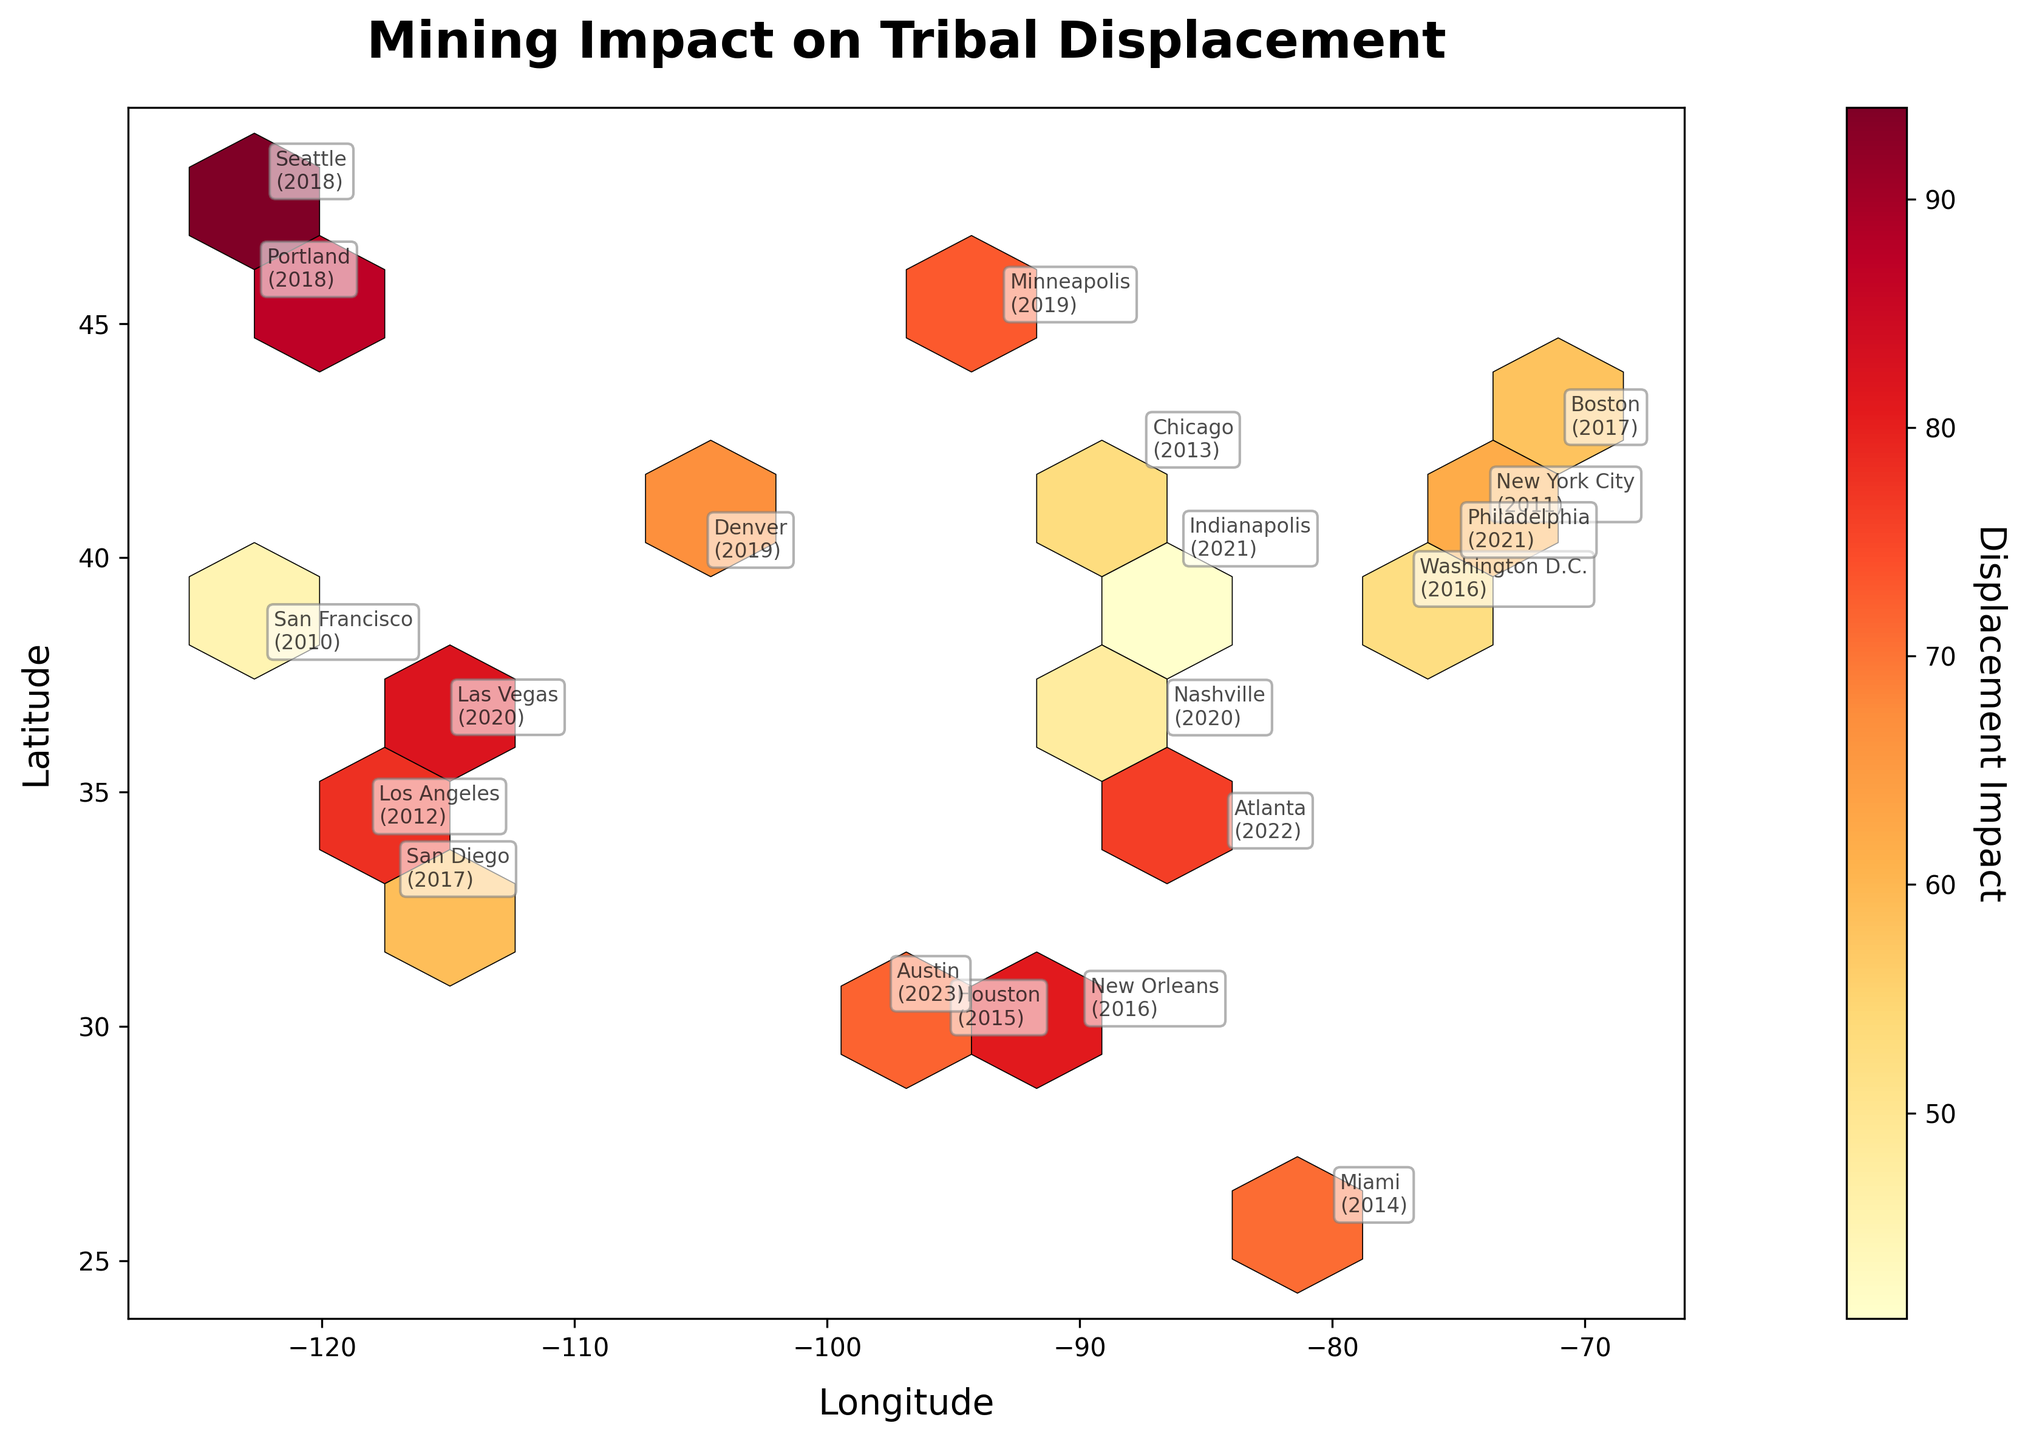What is the color indicating the highest displacement impact on the plot? The color scale denotes displacement impact where darker shades indicate higher impacts. The color bar shows the transition from light yellow to dark red. Dark red represents the highest displacement impact.
Answer: Dark red What is the title of the hexbin plot? The title of the plot is prominently displayed at the top. It is larger and in bold font.
Answer: Mining Impact on Tribal Displacement Which city had the highest displacement impact in 2020? By examining the specific annotations, we identify Las Vegas with a significant displacement impact in 2020.
Answer: Las Vegas How does the displacement impact in Portland (2018) compare to that in San Diego (2017)? By looking at the annotations and their corresponding color intensities, Portland shows a higher color intensity than San Diego. Thus, Portland has a higher displacement impact.
Answer: Portland has a higher impact Which location in 2015 experienced the highest displacement impact? Check the annotation labels for the year 2015 and compare the hexbin color intensities. Houston in 2015 shows a high-impact color intensity.
Answer: Houston How does the displacement impact in Los Angeles (2012) compare to Washington D.C. (2016)? Looking at the hexbin color intensities for these locations, Los Angeles has a darker shade, indicating a higher displacement impact than Washington D.C.
Answer: Los Angeles has a higher impact What range of latitudes are covered in the plot? The y-axis represents latitude. The small annotated points on the plot guide the range estimation. The latitudes range from approximately 25 to 48.
Answer: 25 to 48 What is the general trend of displacement impacts from the west coast to the east coast? By scanning from left to right across the longitude axis, the West Coast locations generally show varied but often higher impacts (darker colors) compared to some East Coast locations.
Answer: Higher impacts on the West Coast How many locations experienced displacement impacts greater than 80? Refer to the annotated values and match them against the color bar to count the locations with impacts greater than 80. There are four such locations: Houston, New Orleans, Seattle, and Las Vegas.
Answer: Four locations Which city's displacement impact in 2019 is closest to the average of all locations? Calculate the average displacement from the provided data, roughly compare it to annotated impacts, and identify which city in 2019 matches closest. Denver with a value of 67 is close to the average displacement.
Answer: Denver 